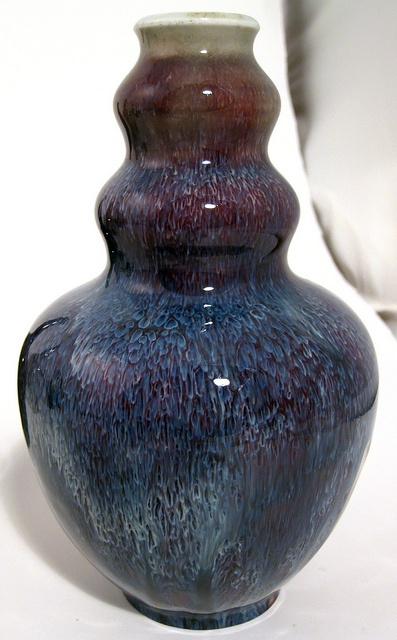Describe the objects in this image and their specific colors. I can see a vase in white, gray, black, navy, and blue tones in this image. 